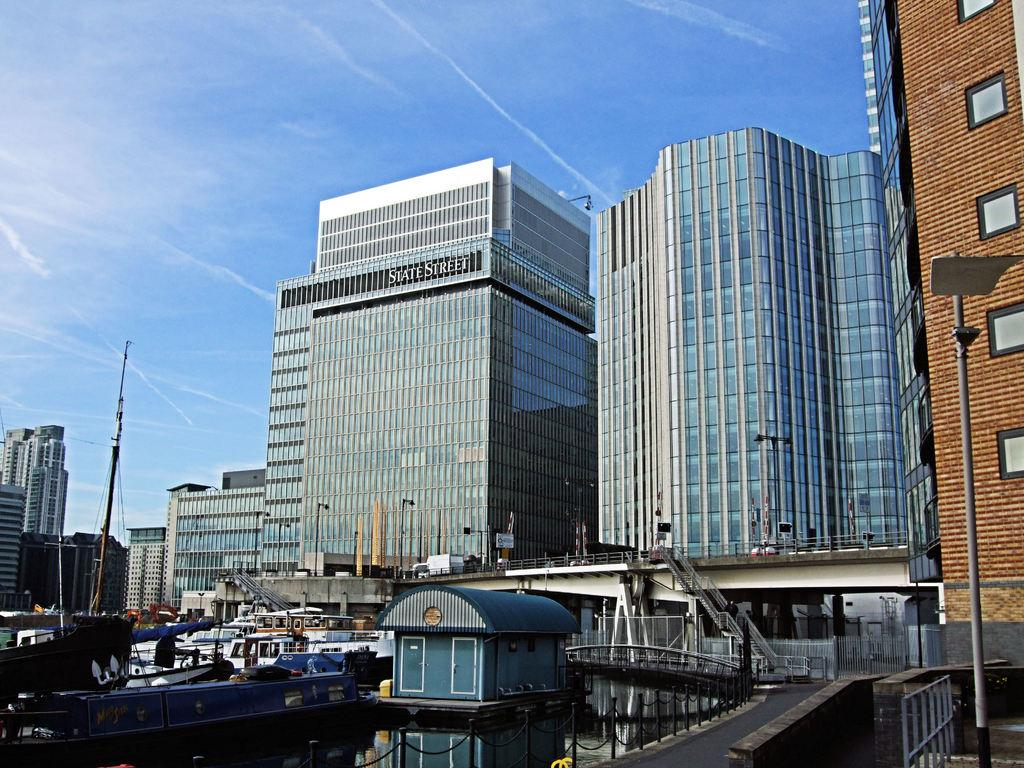What is on the water in the image? There are boats on the water in the image. What type of structure can be seen in the image? There is a shed in the image. What type of barrier is present in the image? There is a fence in the image. What can be seen in the distance in the image? There are buildings and electric poles in the background of the image. What is visible above the structures in the image? The sky is visible in the background of the image. What type of soup is being served in the shed in the image? There is no soup or indication of food in the image; it features boats on the water, a shed, a fence, buildings, electric poles, and the sky. What type of roof is on the shed in the image? The image does not provide enough detail to determine the type of roof on the shed. 